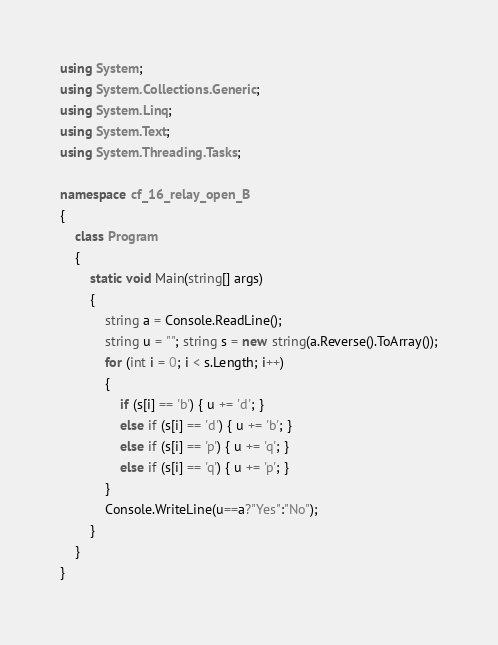<code> <loc_0><loc_0><loc_500><loc_500><_C#_>using System;
using System.Collections.Generic;
using System.Linq;
using System.Text;
using System.Threading.Tasks;

namespace cf_16_relay_open_B
{
    class Program
    {
        static void Main(string[] args)
        {
            string a = Console.ReadLine();
            string u = ""; string s = new string(a.Reverse().ToArray());
            for (int i = 0; i < s.Length; i++)
            {
                if (s[i] == 'b') { u += 'd'; }
                else if (s[i] == 'd') { u += 'b'; }
                else if (s[i] == 'p') { u += 'q'; }
                else if (s[i] == 'q') { u += 'p'; }
            }
            Console.WriteLine(u==a?"Yes":"No");
        }
    }
}
</code> 